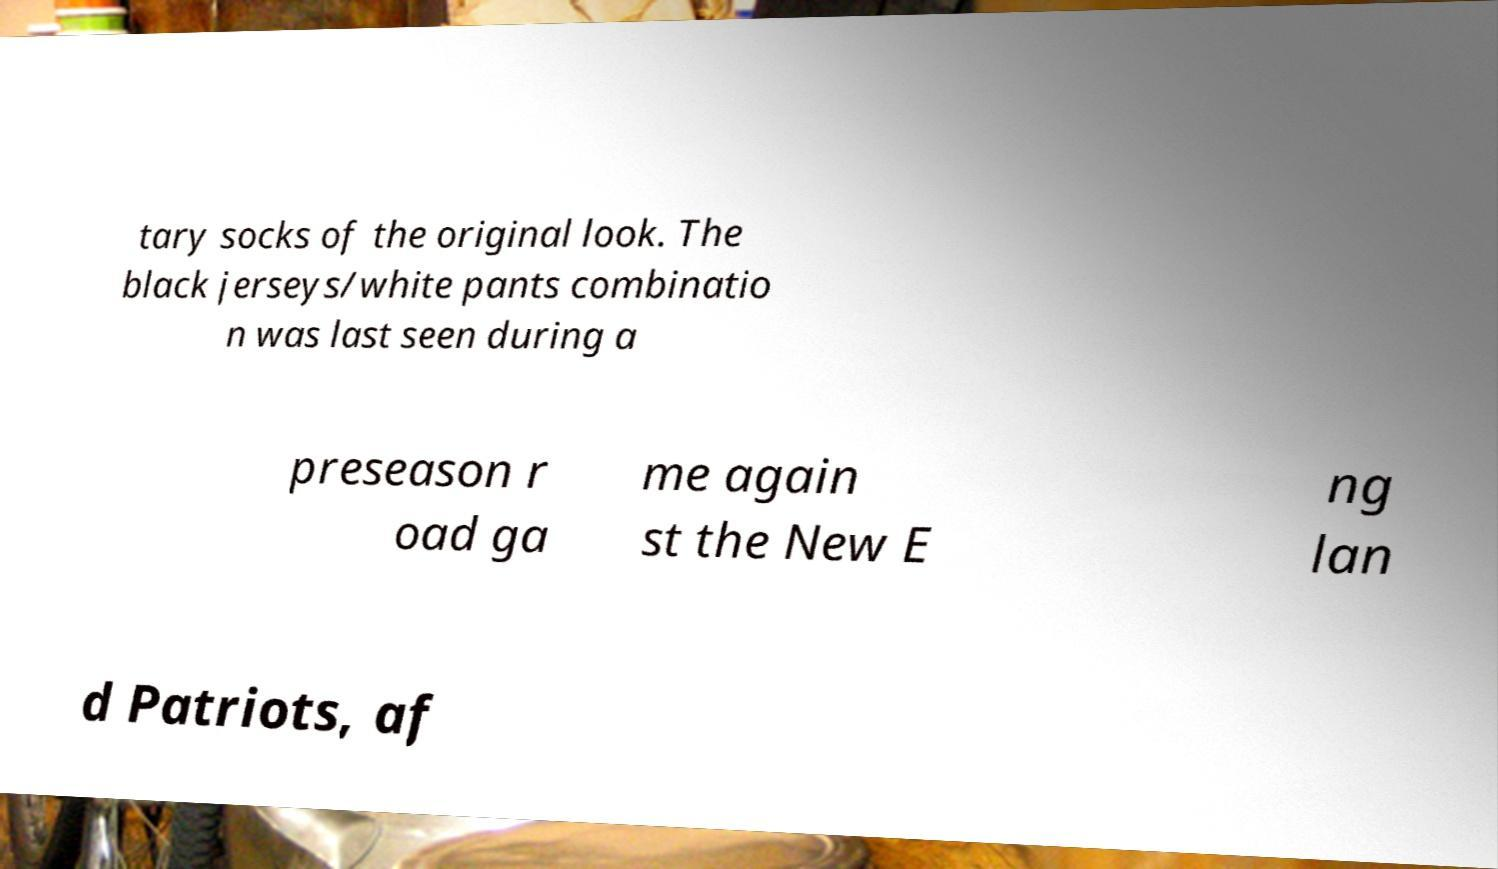What messages or text are displayed in this image? I need them in a readable, typed format. tary socks of the original look. The black jerseys/white pants combinatio n was last seen during a preseason r oad ga me again st the New E ng lan d Patriots, af 